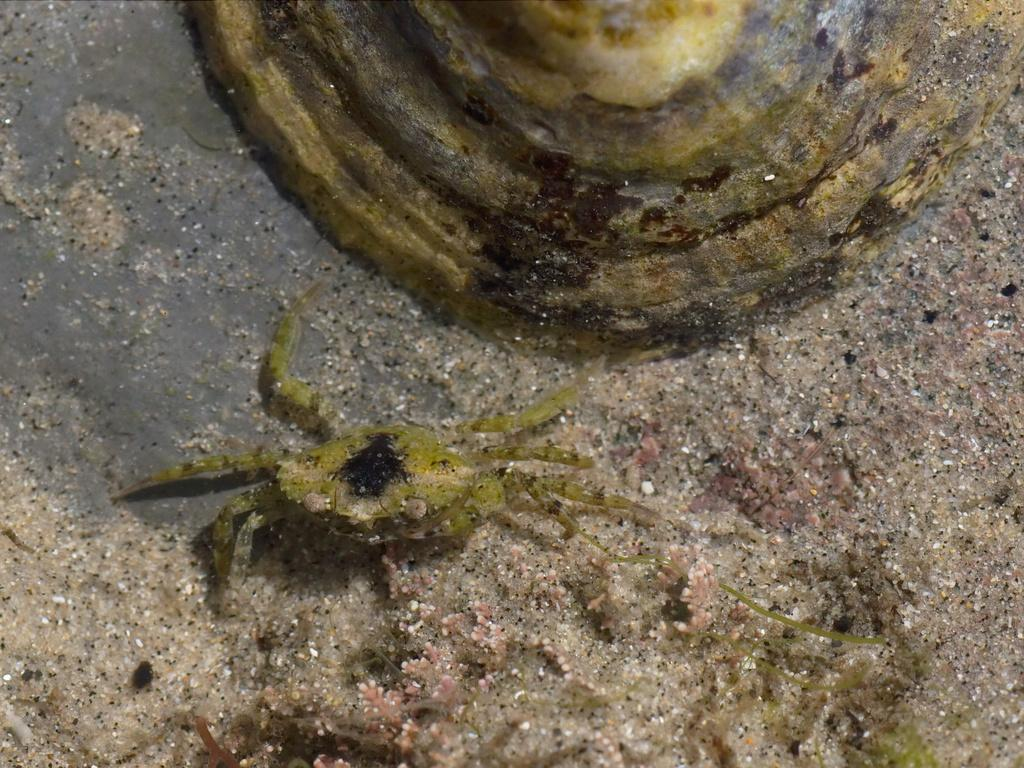What type of animals are present in the image? There are crabs in the image. Where are the crabs located? The crabs are on the sand. Can you describe the background of the image? There is an unspecified object behind the crabs. What type of button is the uncle wearing in the image? There is no uncle or button present in the image; it features crabs on the sand with an unspecified object in the background. 